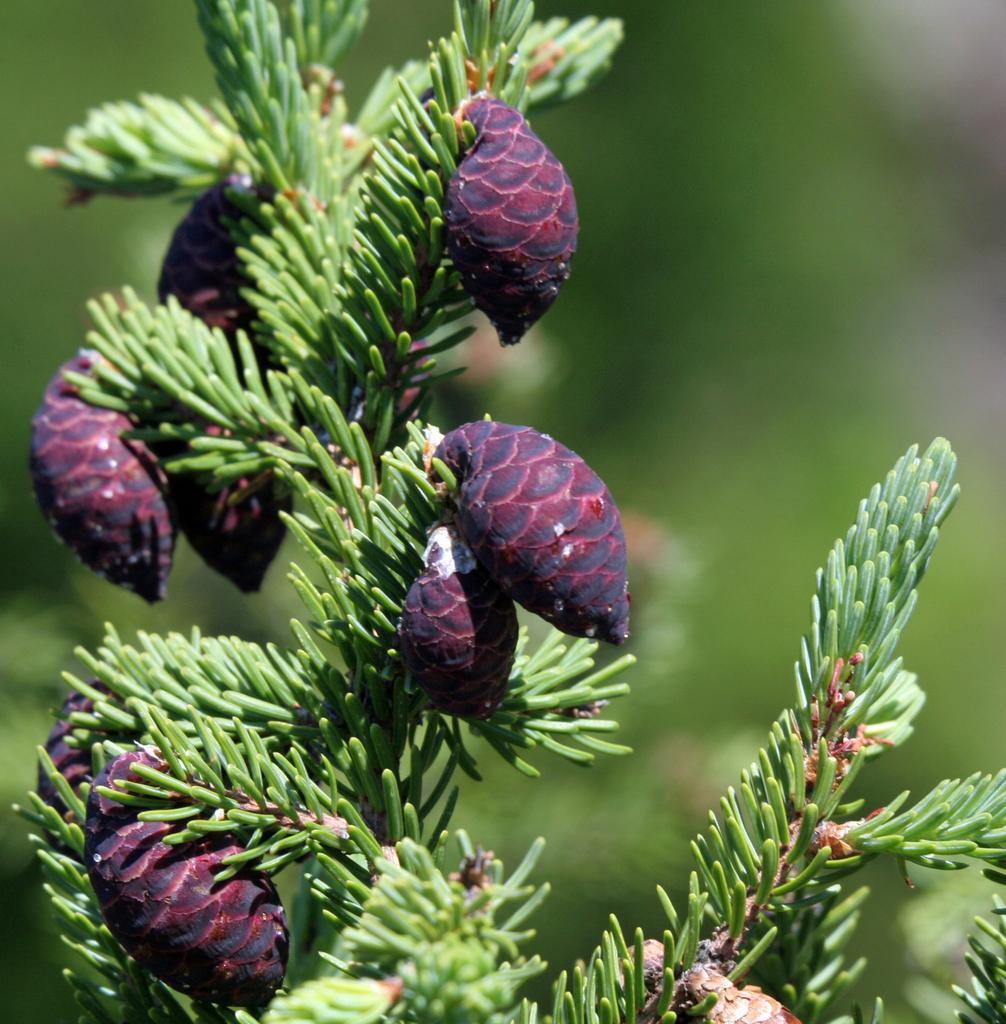Please provide a concise description of this image. In this image I can see few buds to the plant. These bugs are in pink color and there is a blurred background. 